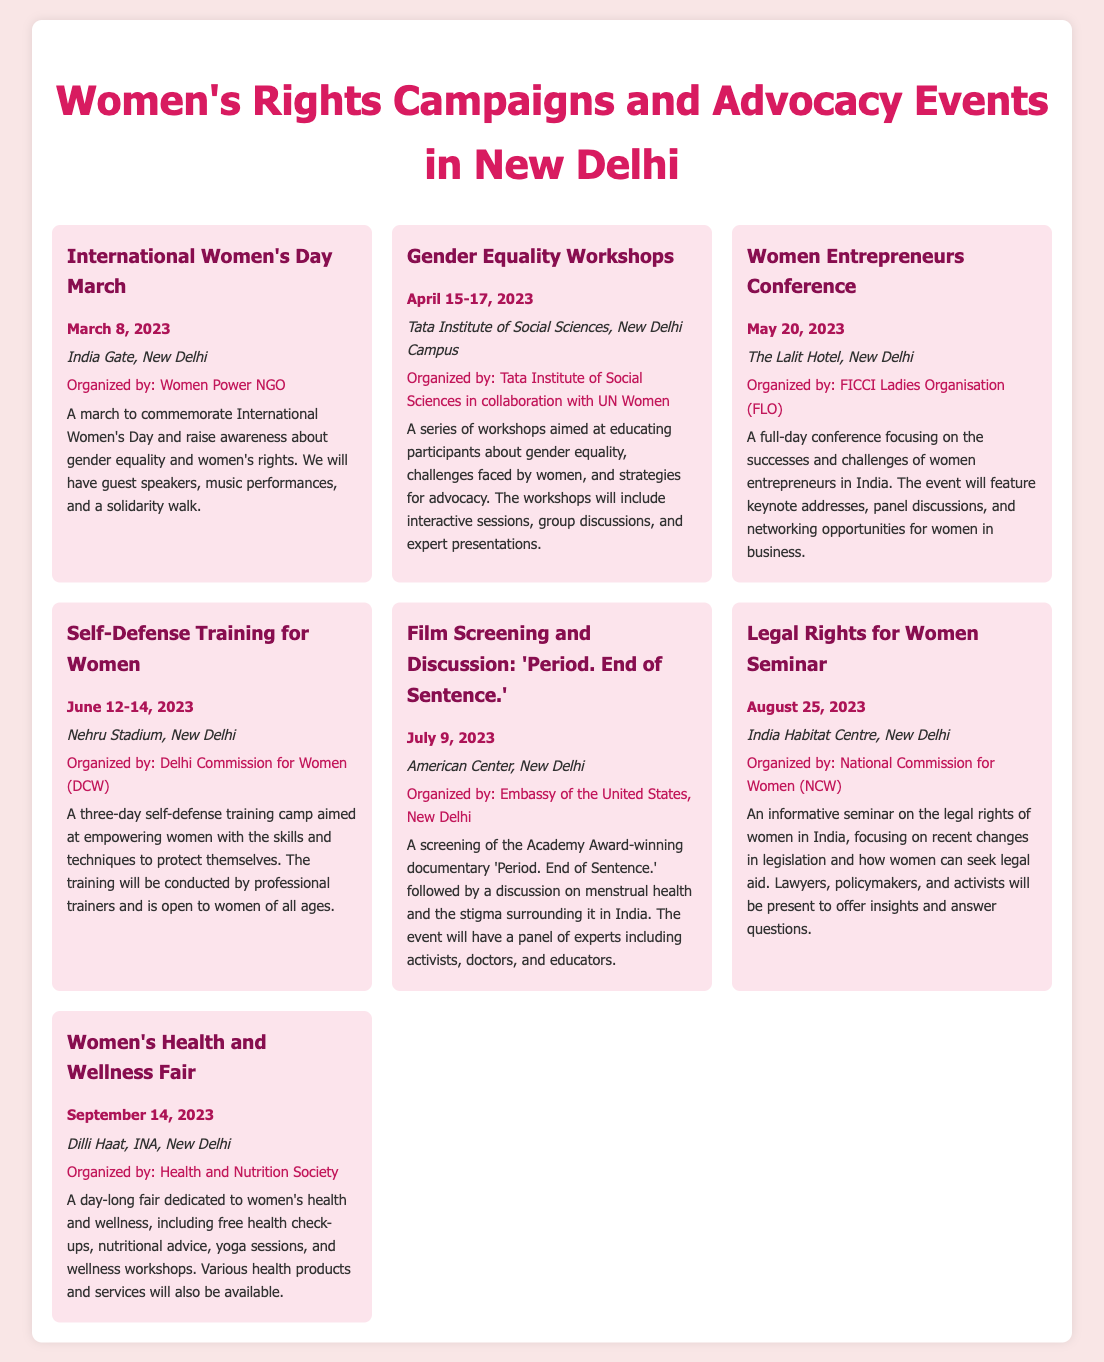What is the date of the International Women's Day March? The date is mentioned in the event details for the International Women's Day March as March 8, 2023.
Answer: March 8, 2023 Who is organizing the Gender Equality Workshops? The organizer is specified in the document as Tata Institute of Social Sciences in collaboration with UN Women.
Answer: Tata Institute of Social Sciences in collaboration with UN Women Where will the Women Entrepreneurs Conference be held? The location for the Women Entrepreneurs Conference is given as The Lalit Hotel, New Delhi.
Answer: The Lalit Hotel, New Delhi What is the date range for the Self-Defense Training for Women? The document provides specific dates for the training as June 12-14, 2023.
Answer: June 12-14, 2023 What type of event is the film screening on July 9, 2023? It is described as a screening followed by a discussion on menstrual health in the document.
Answer: Film Screening and Discussion What is the main focus of the Legal Rights for Women Seminar? The document states that the seminar focuses on the legal rights of women in India.
Answer: Legal rights of women in India Which event includes free health check-ups? The Women's Health and Wellness Fair is mentioned as having free health check-ups.
Answer: Women's Health and Wellness Fair Who will be present at the Women's Health and Wellness Fair? The document refers to various health products and services as part of the fair, but does not specify individual attendees.
Answer: Various health products and services 